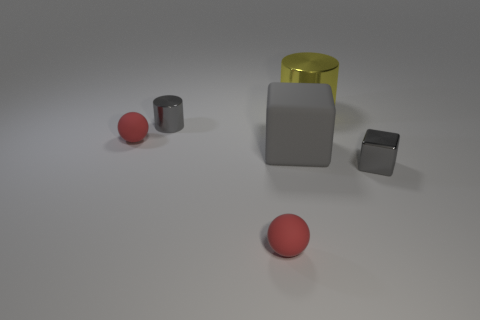What number of tiny cylinders are the same color as the big cube?
Offer a very short reply. 1. How many other objects are the same color as the rubber block?
Give a very brief answer. 2. Is the number of big gray rubber objects greater than the number of large red cubes?
Offer a very short reply. Yes. What is the yellow cylinder made of?
Ensure brevity in your answer.  Metal. Is the size of the gray metallic thing that is on the right side of the yellow metallic object the same as the matte block?
Your answer should be compact. No. What is the size of the ball behind the large gray matte thing?
Provide a short and direct response. Small. Is there anything else that has the same material as the small cylinder?
Give a very brief answer. Yes. What number of gray matte blocks are there?
Offer a very short reply. 1. Do the small metallic cube and the big matte object have the same color?
Your answer should be very brief. Yes. What color is the matte object that is left of the gray matte cube and behind the small gray shiny cube?
Offer a very short reply. Red. 